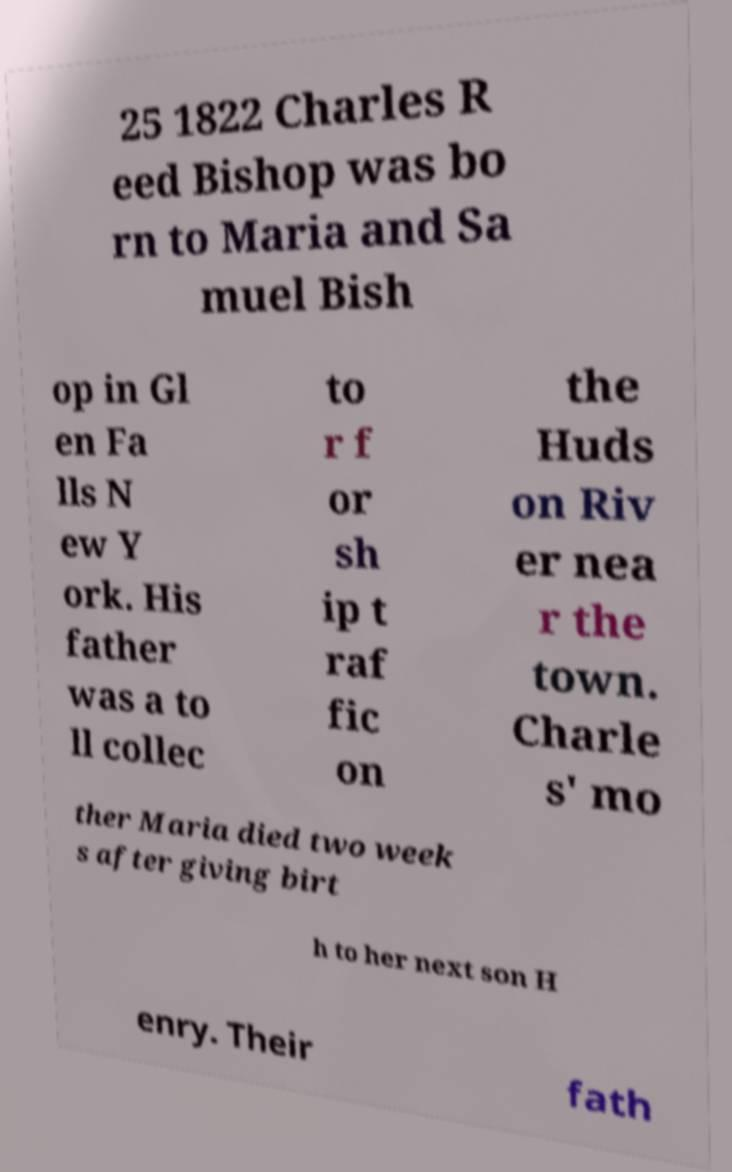What messages or text are displayed in this image? I need them in a readable, typed format. 25 1822 Charles R eed Bishop was bo rn to Maria and Sa muel Bish op in Gl en Fa lls N ew Y ork. His father was a to ll collec to r f or sh ip t raf fic on the Huds on Riv er nea r the town. Charle s' mo ther Maria died two week s after giving birt h to her next son H enry. Their fath 